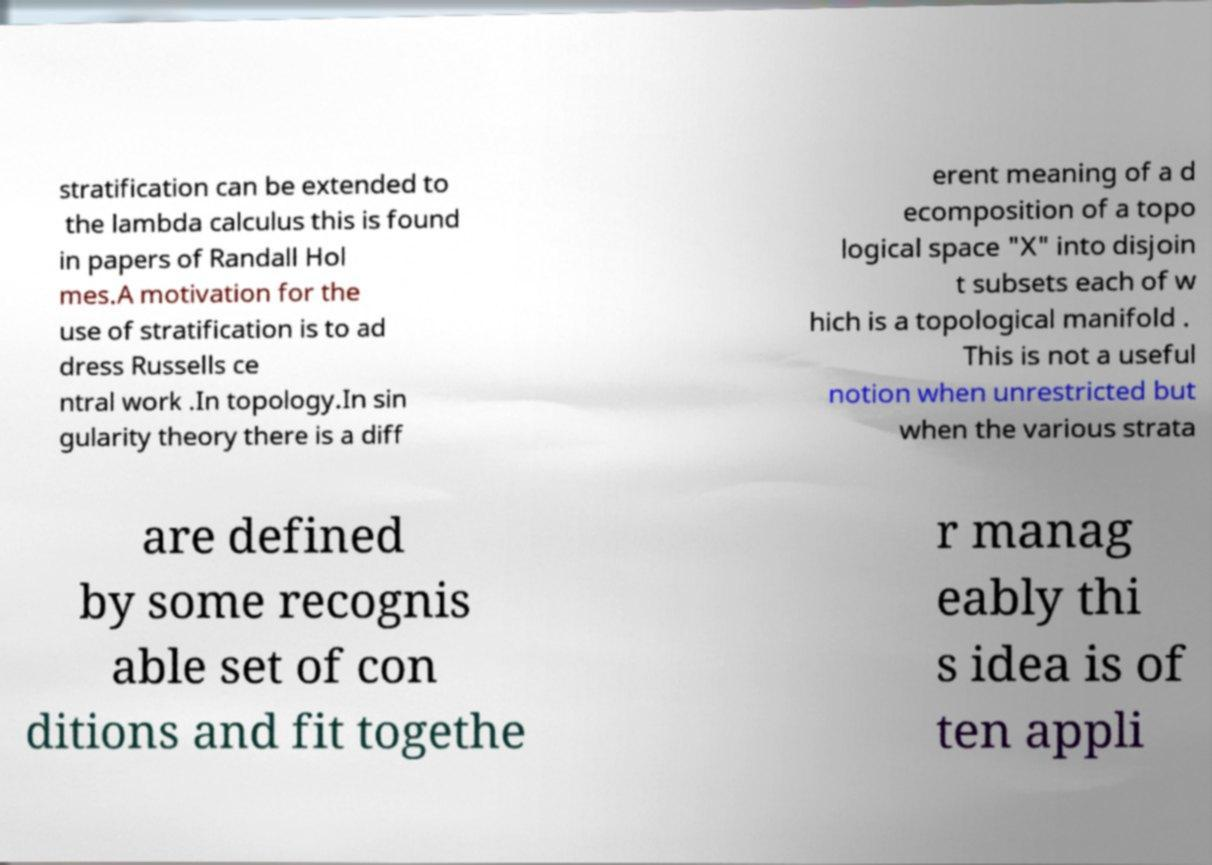There's text embedded in this image that I need extracted. Can you transcribe it verbatim? stratification can be extended to the lambda calculus this is found in papers of Randall Hol mes.A motivation for the use of stratification is to ad dress Russells ce ntral work .In topology.In sin gularity theory there is a diff erent meaning of a d ecomposition of a topo logical space "X" into disjoin t subsets each of w hich is a topological manifold . This is not a useful notion when unrestricted but when the various strata are defined by some recognis able set of con ditions and fit togethe r manag eably thi s idea is of ten appli 